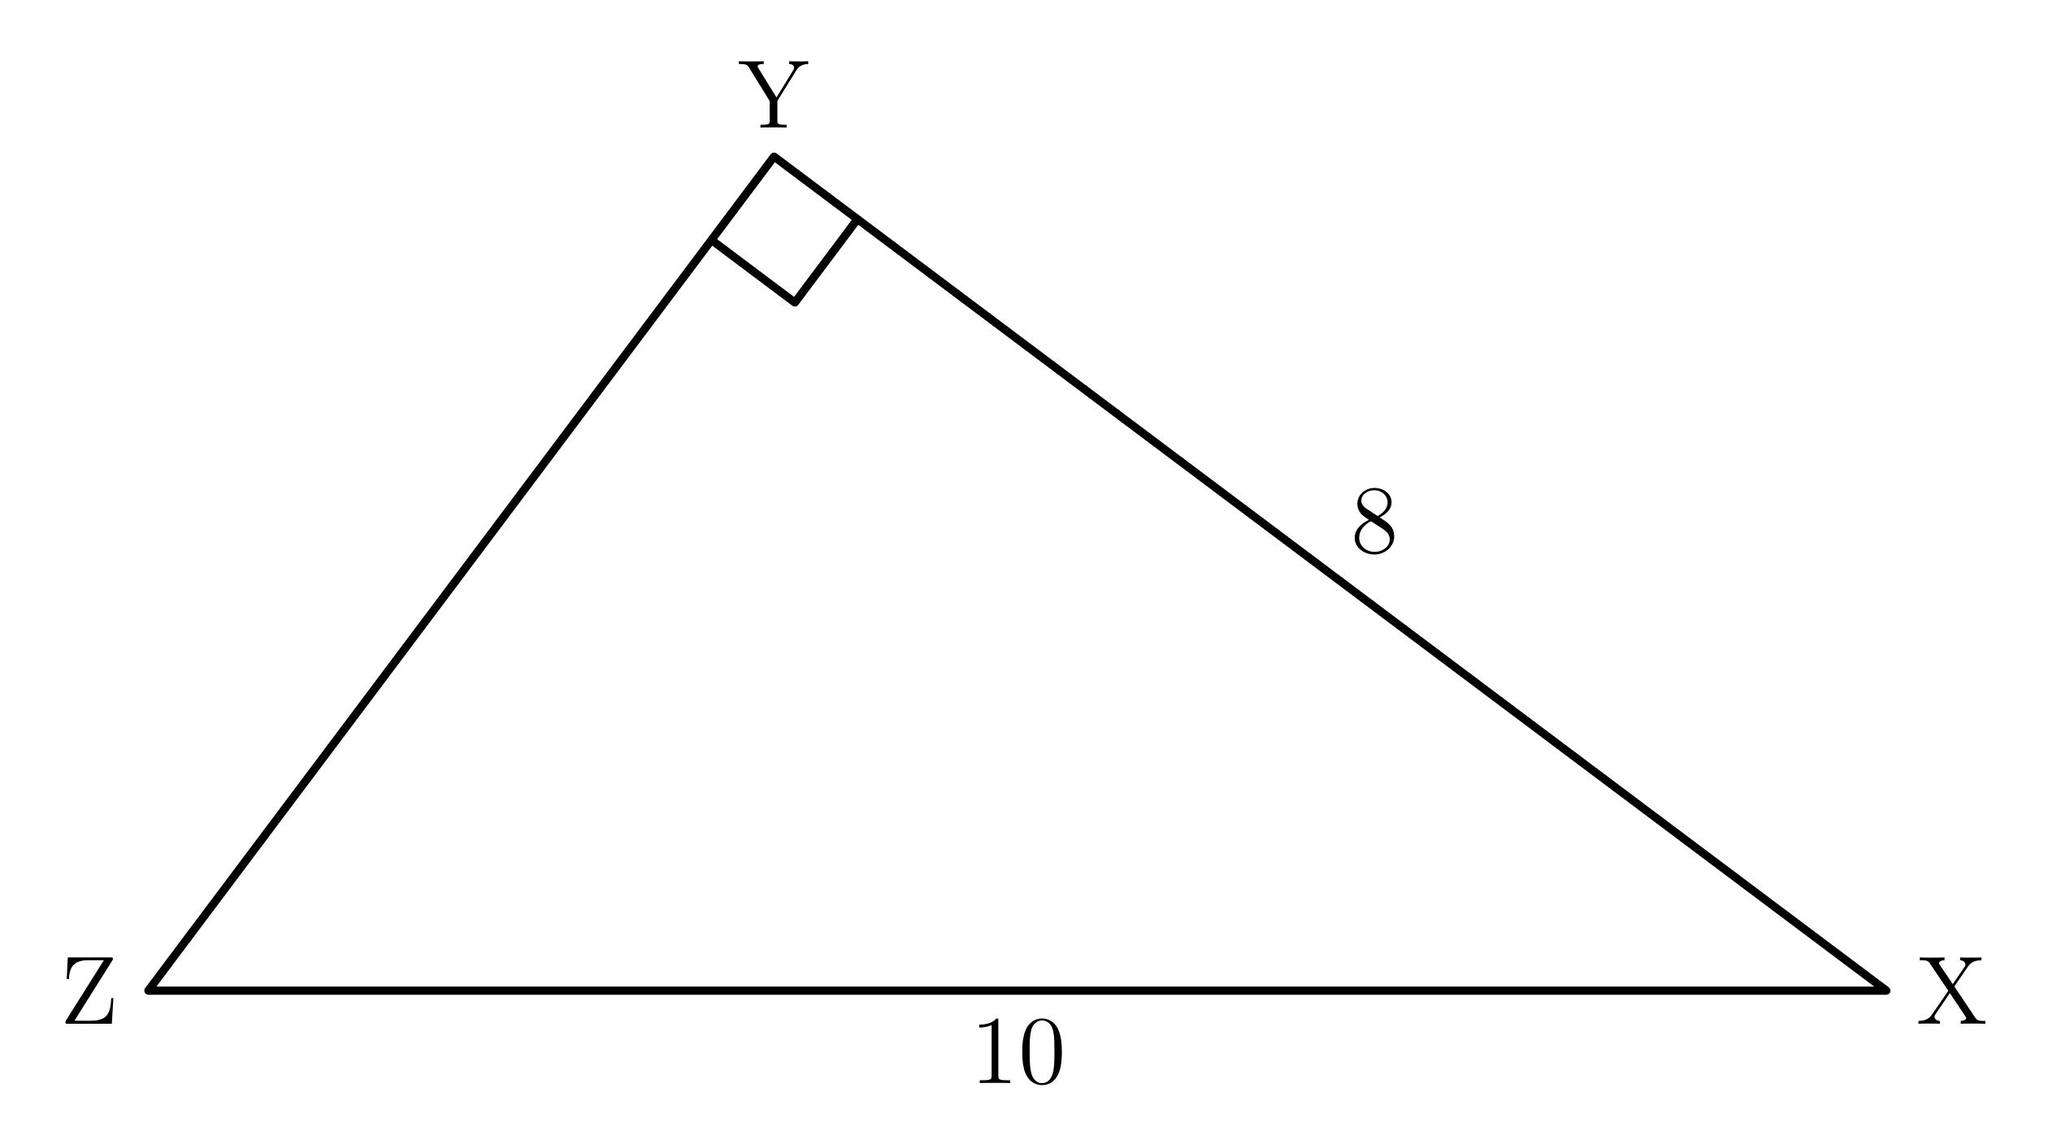How would you find the tangent of angle Y in this triangle? To find the tangent of angle Y, which is the angle at the vertex between sides XY and YZ, you need to use the tangent trigonometric ratio, which is the opposite side over the adjacent side. Since XYZ is a right triangle with a right angle at X, the tangent of Y would be the length of XZ divided by the length of XY. The tangent of angle Y is 8/10, simplifying to 4/5. 